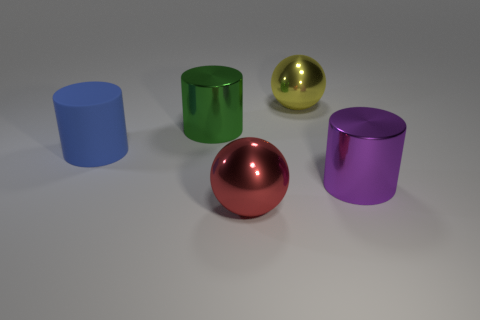Subtract all blue cylinders. How many cylinders are left? 2 Add 3 large yellow spheres. How many objects exist? 8 Subtract all brown cylinders. Subtract all yellow cubes. How many cylinders are left? 3 Subtract all balls. How many objects are left? 3 Add 2 purple cylinders. How many purple cylinders are left? 3 Add 4 brown matte cylinders. How many brown matte cylinders exist? 4 Subtract 0 brown balls. How many objects are left? 5 Subtract all big green shiny objects. Subtract all red metal objects. How many objects are left? 3 